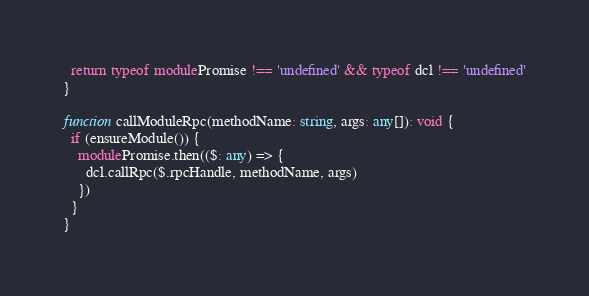Convert code to text. <code><loc_0><loc_0><loc_500><loc_500><_TypeScript_>  return typeof modulePromise !== 'undefined' && typeof dcl !== 'undefined'
}

function callModuleRpc(methodName: string, args: any[]): void {
  if (ensureModule()) {
    modulePromise.then(($: any) => {
      dcl.callRpc($.rpcHandle, methodName, args)
    })
  }
}
</code> 